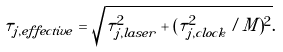Convert formula to latex. <formula><loc_0><loc_0><loc_500><loc_500>\tau _ { j , e f f e c t i v e } = \sqrt { \tau _ { j , l a s e r } ^ { 2 } + ( \tau _ { j , c l o c k } ^ { 2 } / M ) ^ { 2 } } .</formula> 